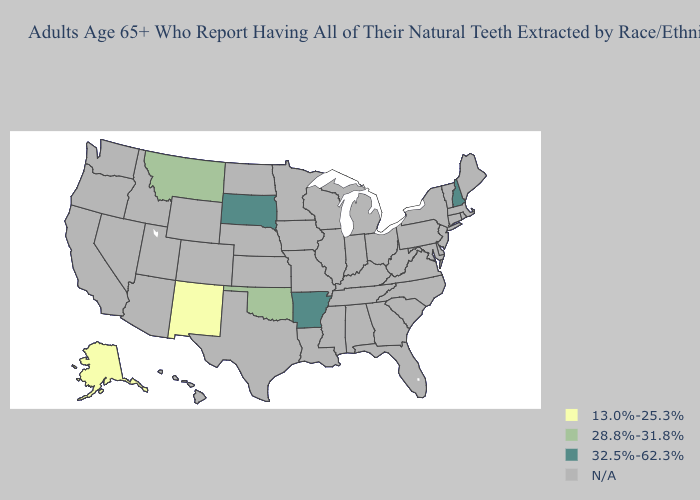What is the value of Louisiana?
Answer briefly. N/A. What is the lowest value in the South?
Give a very brief answer. 28.8%-31.8%. Which states have the highest value in the USA?
Write a very short answer. Arkansas, New Hampshire, South Dakota. What is the value of Idaho?
Write a very short answer. N/A. Name the states that have a value in the range N/A?
Answer briefly. Alabama, Arizona, California, Colorado, Connecticut, Delaware, Florida, Georgia, Hawaii, Idaho, Illinois, Indiana, Iowa, Kansas, Kentucky, Louisiana, Maine, Maryland, Massachusetts, Michigan, Minnesota, Mississippi, Missouri, Nebraska, Nevada, New Jersey, New York, North Carolina, North Dakota, Ohio, Oregon, Pennsylvania, Rhode Island, South Carolina, Tennessee, Texas, Utah, Vermont, Virginia, Washington, West Virginia, Wisconsin, Wyoming. Does Oklahoma have the highest value in the USA?
Concise answer only. No. Which states have the lowest value in the USA?
Write a very short answer. Alaska, New Mexico. Name the states that have a value in the range N/A?
Short answer required. Alabama, Arizona, California, Colorado, Connecticut, Delaware, Florida, Georgia, Hawaii, Idaho, Illinois, Indiana, Iowa, Kansas, Kentucky, Louisiana, Maine, Maryland, Massachusetts, Michigan, Minnesota, Mississippi, Missouri, Nebraska, Nevada, New Jersey, New York, North Carolina, North Dakota, Ohio, Oregon, Pennsylvania, Rhode Island, South Carolina, Tennessee, Texas, Utah, Vermont, Virginia, Washington, West Virginia, Wisconsin, Wyoming. What is the value of New Jersey?
Write a very short answer. N/A. Does the map have missing data?
Give a very brief answer. Yes. Which states hav the highest value in the West?
Quick response, please. Montana. Name the states that have a value in the range 13.0%-25.3%?
Write a very short answer. Alaska, New Mexico. How many symbols are there in the legend?
Be succinct. 4. 